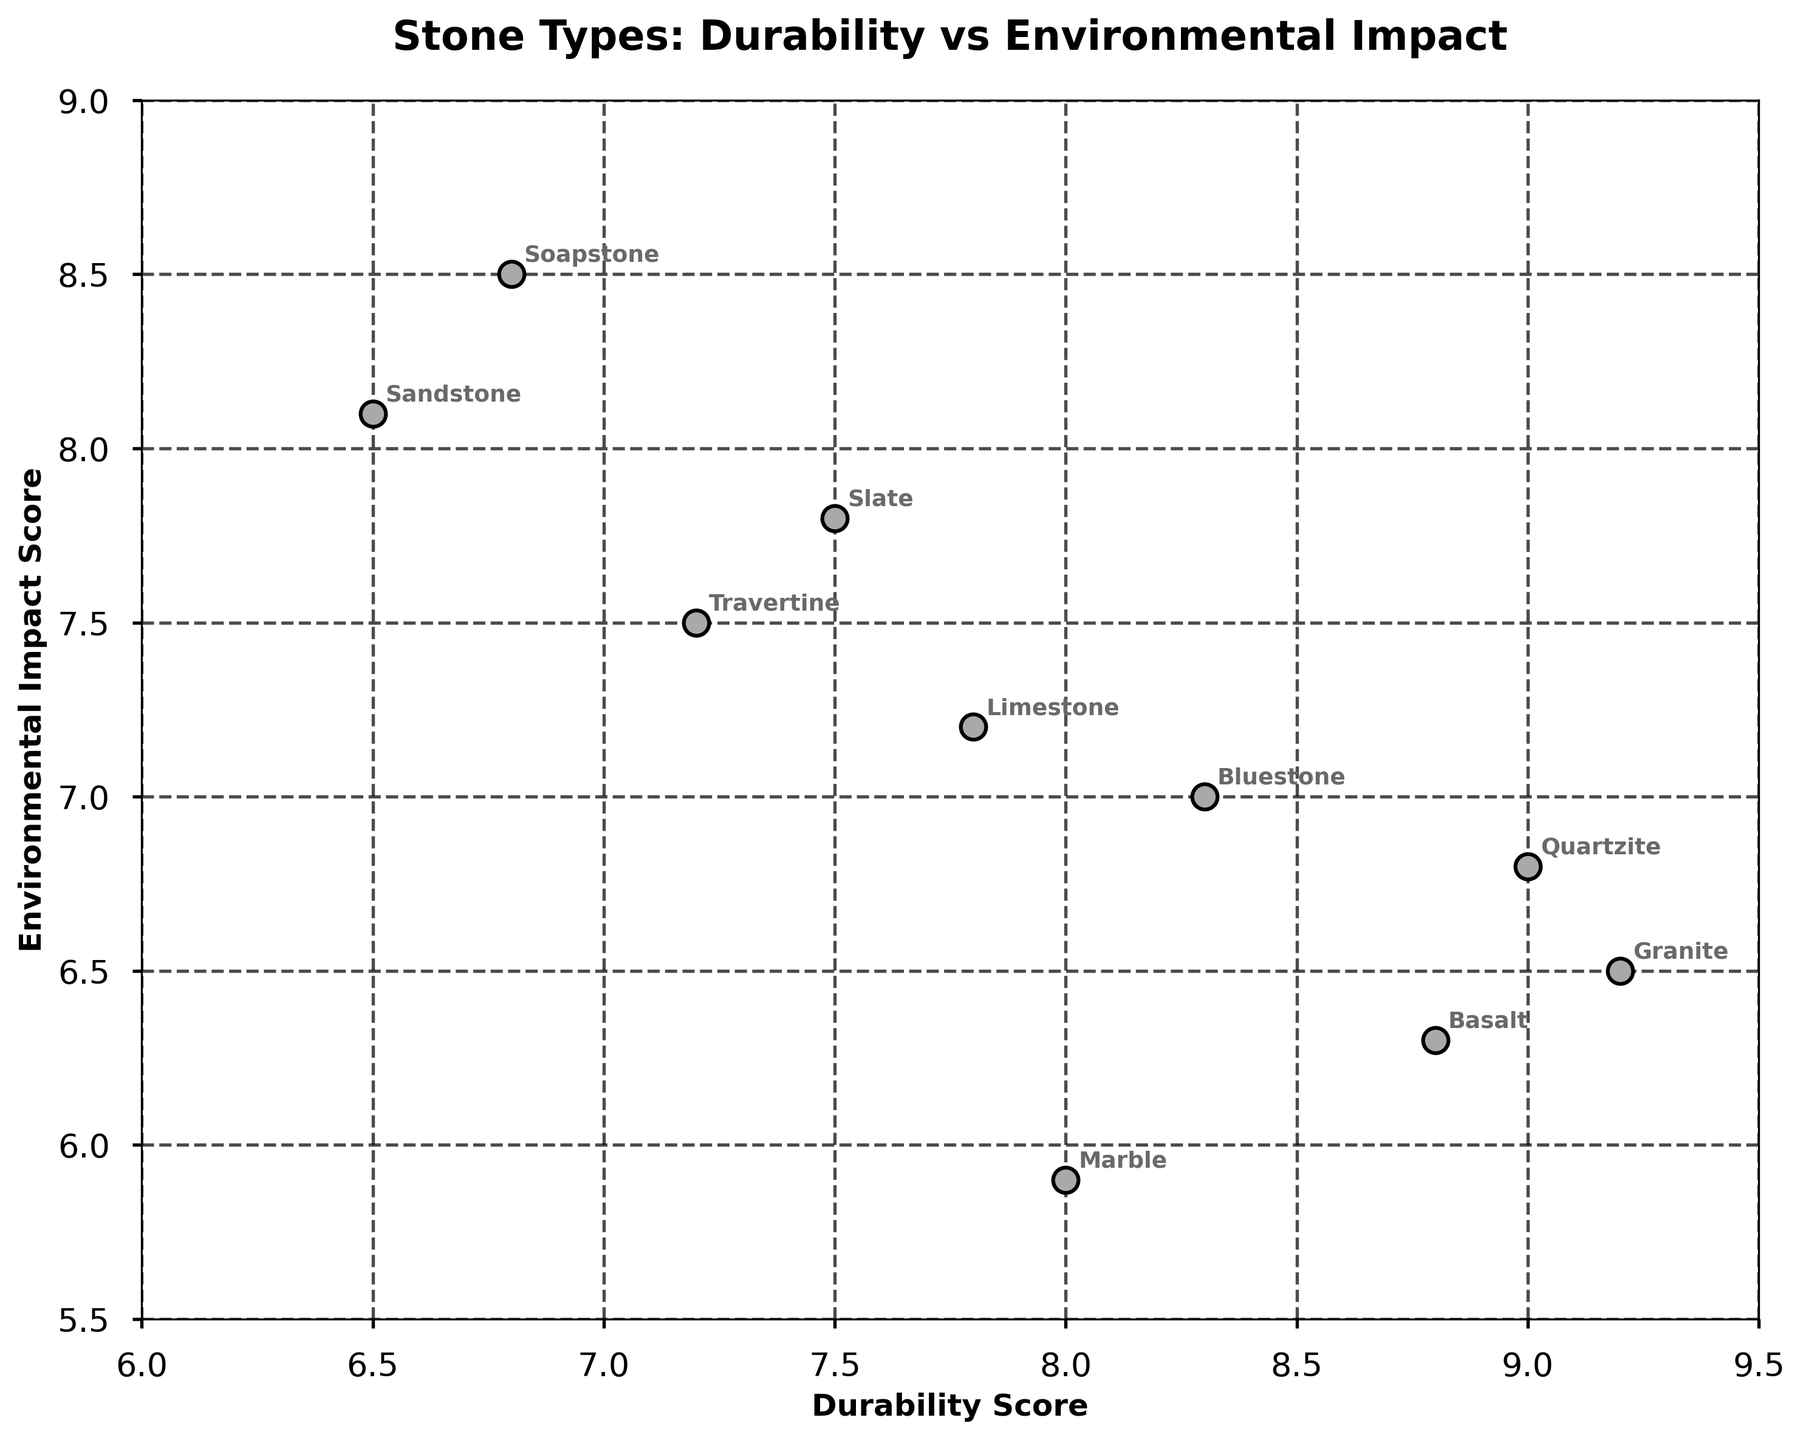What's the stone type with the highest Durability Score? Look for the stone type with the highest value on the x-axis, which represents the Durability Score. In this case, it's Granite with a score of 9.2.
Answer: Granite Which stone type has the lowest Environmental Impact Score? Identify the stone type that has the lowest value on the y-axis. Marble appears to have the lowest Environmental Impact Score of 5.9.
Answer: Marble What's the average Durability Score of all stone types? Sum all the Durability Scores and then divide by the number of stone types. (9.2 + 7.8 + 6.5 + 8.0 + 7.5 + 9.0 + 7.2 + 8.8 + 6.8 + 8.3)/10 = 7.91
Answer: 7.91 How many stone types have an Environmental Impact Score greater than 7? Count the number of data points where the y-axis value is greater than 7. Limestone, Sandstone, Slate, Travertine, Soapstone, and Bluestone meet this criterion, which makes it 6 stone types.
Answer: 6 Which stone type is closest to the average Environmental Impact Score? Calculate the average Environmental Impact Score (6.5 + 7.2 + 8.1 + 5.9 + 7.8 + 6.8 + 7.5 + 6.3 + 8.5 + 7.0)/10 = 7.11. Limestone's score of 7.2 is the closest to this average.
Answer: Limestone Is there a stone type with both a Durability Score higher than 8 and an Environmental Impact Score lower than 6? Check if any stone type meets both conditions. Granite has a Durability Score of 9.2 and an Environmental Impact Score of 6.5, and Basalt has 8.8 and 6.3, respectively. No examples fit both criteria.
Answer: No Which stone type has a combination of low Durability Score and high Environmental Impact Score? Look for a stone type represented by a point on the left side (low Durability) and higher on the y-axis (high Environmental Impact). Soapstone has a Durability Score of 6.8 and an Environmental Impact Score of 8.5.
Answer: Soapstone 